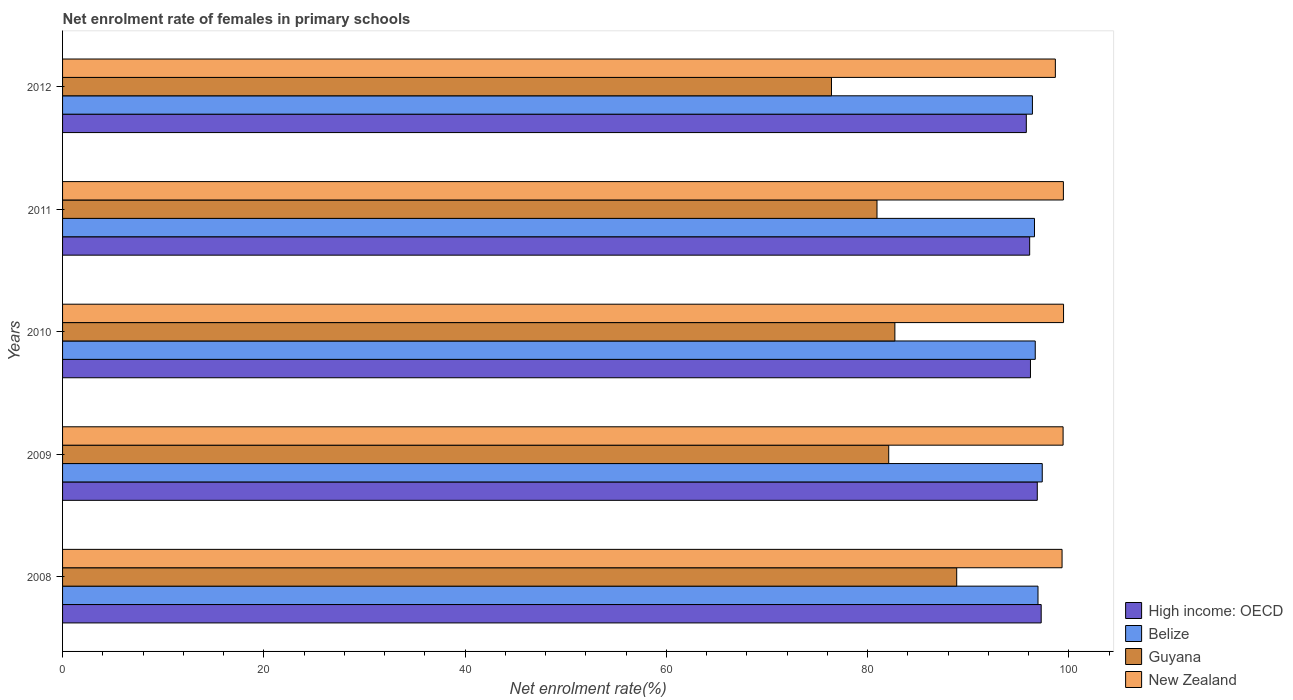How many groups of bars are there?
Ensure brevity in your answer.  5. Are the number of bars per tick equal to the number of legend labels?
Your response must be concise. Yes. Are the number of bars on each tick of the Y-axis equal?
Make the answer very short. Yes. How many bars are there on the 2nd tick from the top?
Ensure brevity in your answer.  4. How many bars are there on the 5th tick from the bottom?
Your answer should be compact. 4. In how many cases, is the number of bars for a given year not equal to the number of legend labels?
Keep it short and to the point. 0. What is the net enrolment rate of females in primary schools in High income: OECD in 2010?
Make the answer very short. 96.19. Across all years, what is the maximum net enrolment rate of females in primary schools in Guyana?
Provide a short and direct response. 88.86. Across all years, what is the minimum net enrolment rate of females in primary schools in New Zealand?
Keep it short and to the point. 98.67. What is the total net enrolment rate of females in primary schools in Guyana in the graph?
Your response must be concise. 411.05. What is the difference between the net enrolment rate of females in primary schools in Belize in 2008 and that in 2009?
Offer a terse response. -0.42. What is the difference between the net enrolment rate of females in primary schools in New Zealand in 2010 and the net enrolment rate of females in primary schools in Belize in 2009?
Your answer should be very brief. 2.12. What is the average net enrolment rate of females in primary schools in Belize per year?
Offer a terse response. 96.79. In the year 2012, what is the difference between the net enrolment rate of females in primary schools in High income: OECD and net enrolment rate of females in primary schools in Guyana?
Provide a short and direct response. 19.36. In how many years, is the net enrolment rate of females in primary schools in Belize greater than 8 %?
Ensure brevity in your answer.  5. What is the ratio of the net enrolment rate of females in primary schools in New Zealand in 2008 to that in 2011?
Offer a terse response. 1. Is the net enrolment rate of females in primary schools in Belize in 2009 less than that in 2010?
Offer a terse response. No. Is the difference between the net enrolment rate of females in primary schools in High income: OECD in 2008 and 2012 greater than the difference between the net enrolment rate of females in primary schools in Guyana in 2008 and 2012?
Make the answer very short. No. What is the difference between the highest and the second highest net enrolment rate of females in primary schools in Guyana?
Make the answer very short. 6.14. What is the difference between the highest and the lowest net enrolment rate of females in primary schools in High income: OECD?
Give a very brief answer. 1.48. Is it the case that in every year, the sum of the net enrolment rate of females in primary schools in High income: OECD and net enrolment rate of females in primary schools in New Zealand is greater than the sum of net enrolment rate of females in primary schools in Belize and net enrolment rate of females in primary schools in Guyana?
Offer a terse response. Yes. What does the 4th bar from the top in 2009 represents?
Keep it short and to the point. High income: OECD. What does the 1st bar from the bottom in 2010 represents?
Ensure brevity in your answer.  High income: OECD. Is it the case that in every year, the sum of the net enrolment rate of females in primary schools in Guyana and net enrolment rate of females in primary schools in High income: OECD is greater than the net enrolment rate of females in primary schools in Belize?
Your answer should be very brief. Yes. How many bars are there?
Offer a very short reply. 20. How many years are there in the graph?
Your response must be concise. 5. Are the values on the major ticks of X-axis written in scientific E-notation?
Make the answer very short. No. What is the title of the graph?
Give a very brief answer. Net enrolment rate of females in primary schools. What is the label or title of the X-axis?
Provide a short and direct response. Net enrolment rate(%). What is the Net enrolment rate(%) of High income: OECD in 2008?
Provide a short and direct response. 97.26. What is the Net enrolment rate(%) in Belize in 2008?
Make the answer very short. 96.94. What is the Net enrolment rate(%) in Guyana in 2008?
Your answer should be very brief. 88.86. What is the Net enrolment rate(%) in New Zealand in 2008?
Make the answer very short. 99.34. What is the Net enrolment rate(%) of High income: OECD in 2009?
Give a very brief answer. 96.87. What is the Net enrolment rate(%) of Belize in 2009?
Your answer should be very brief. 97.37. What is the Net enrolment rate(%) in Guyana in 2009?
Ensure brevity in your answer.  82.11. What is the Net enrolment rate(%) in New Zealand in 2009?
Offer a very short reply. 99.44. What is the Net enrolment rate(%) in High income: OECD in 2010?
Provide a short and direct response. 96.19. What is the Net enrolment rate(%) in Belize in 2010?
Your answer should be compact. 96.67. What is the Net enrolment rate(%) of Guyana in 2010?
Your answer should be compact. 82.72. What is the Net enrolment rate(%) of New Zealand in 2010?
Your answer should be compact. 99.48. What is the Net enrolment rate(%) of High income: OECD in 2011?
Ensure brevity in your answer.  96.12. What is the Net enrolment rate(%) in Belize in 2011?
Your answer should be very brief. 96.59. What is the Net enrolment rate(%) of Guyana in 2011?
Give a very brief answer. 80.94. What is the Net enrolment rate(%) of New Zealand in 2011?
Offer a very short reply. 99.47. What is the Net enrolment rate(%) of High income: OECD in 2012?
Provide a short and direct response. 95.78. What is the Net enrolment rate(%) in Belize in 2012?
Your answer should be compact. 96.39. What is the Net enrolment rate(%) in Guyana in 2012?
Provide a succinct answer. 76.42. What is the Net enrolment rate(%) in New Zealand in 2012?
Provide a succinct answer. 98.67. Across all years, what is the maximum Net enrolment rate(%) of High income: OECD?
Your answer should be compact. 97.26. Across all years, what is the maximum Net enrolment rate(%) in Belize?
Your response must be concise. 97.37. Across all years, what is the maximum Net enrolment rate(%) in Guyana?
Make the answer very short. 88.86. Across all years, what is the maximum Net enrolment rate(%) in New Zealand?
Keep it short and to the point. 99.48. Across all years, what is the minimum Net enrolment rate(%) in High income: OECD?
Your response must be concise. 95.78. Across all years, what is the minimum Net enrolment rate(%) of Belize?
Provide a succinct answer. 96.39. Across all years, what is the minimum Net enrolment rate(%) in Guyana?
Keep it short and to the point. 76.42. Across all years, what is the minimum Net enrolment rate(%) in New Zealand?
Offer a terse response. 98.67. What is the total Net enrolment rate(%) in High income: OECD in the graph?
Your answer should be compact. 482.22. What is the total Net enrolment rate(%) of Belize in the graph?
Ensure brevity in your answer.  483.96. What is the total Net enrolment rate(%) in Guyana in the graph?
Provide a short and direct response. 411.05. What is the total Net enrolment rate(%) in New Zealand in the graph?
Offer a very short reply. 496.39. What is the difference between the Net enrolment rate(%) in High income: OECD in 2008 and that in 2009?
Provide a succinct answer. 0.39. What is the difference between the Net enrolment rate(%) in Belize in 2008 and that in 2009?
Keep it short and to the point. -0.42. What is the difference between the Net enrolment rate(%) in Guyana in 2008 and that in 2009?
Your answer should be compact. 6.76. What is the difference between the Net enrolment rate(%) in New Zealand in 2008 and that in 2009?
Your answer should be very brief. -0.1. What is the difference between the Net enrolment rate(%) of High income: OECD in 2008 and that in 2010?
Keep it short and to the point. 1.07. What is the difference between the Net enrolment rate(%) in Belize in 2008 and that in 2010?
Make the answer very short. 0.27. What is the difference between the Net enrolment rate(%) in Guyana in 2008 and that in 2010?
Provide a short and direct response. 6.14. What is the difference between the Net enrolment rate(%) of New Zealand in 2008 and that in 2010?
Ensure brevity in your answer.  -0.15. What is the difference between the Net enrolment rate(%) of High income: OECD in 2008 and that in 2011?
Offer a very short reply. 1.15. What is the difference between the Net enrolment rate(%) of Guyana in 2008 and that in 2011?
Keep it short and to the point. 7.92. What is the difference between the Net enrolment rate(%) of New Zealand in 2008 and that in 2011?
Ensure brevity in your answer.  -0.13. What is the difference between the Net enrolment rate(%) in High income: OECD in 2008 and that in 2012?
Provide a short and direct response. 1.48. What is the difference between the Net enrolment rate(%) of Belize in 2008 and that in 2012?
Keep it short and to the point. 0.56. What is the difference between the Net enrolment rate(%) in Guyana in 2008 and that in 2012?
Offer a terse response. 12.44. What is the difference between the Net enrolment rate(%) in New Zealand in 2008 and that in 2012?
Provide a succinct answer. 0.67. What is the difference between the Net enrolment rate(%) in High income: OECD in 2009 and that in 2010?
Your response must be concise. 0.68. What is the difference between the Net enrolment rate(%) in Belize in 2009 and that in 2010?
Provide a short and direct response. 0.69. What is the difference between the Net enrolment rate(%) in Guyana in 2009 and that in 2010?
Provide a short and direct response. -0.61. What is the difference between the Net enrolment rate(%) in New Zealand in 2009 and that in 2010?
Give a very brief answer. -0.04. What is the difference between the Net enrolment rate(%) in High income: OECD in 2009 and that in 2011?
Keep it short and to the point. 0.76. What is the difference between the Net enrolment rate(%) in Belize in 2009 and that in 2011?
Offer a terse response. 0.77. What is the difference between the Net enrolment rate(%) in Guyana in 2009 and that in 2011?
Offer a very short reply. 1.17. What is the difference between the Net enrolment rate(%) in New Zealand in 2009 and that in 2011?
Offer a terse response. -0.03. What is the difference between the Net enrolment rate(%) of High income: OECD in 2009 and that in 2012?
Make the answer very short. 1.09. What is the difference between the Net enrolment rate(%) in Belize in 2009 and that in 2012?
Give a very brief answer. 0.98. What is the difference between the Net enrolment rate(%) in Guyana in 2009 and that in 2012?
Your answer should be compact. 5.69. What is the difference between the Net enrolment rate(%) in New Zealand in 2009 and that in 2012?
Your response must be concise. 0.77. What is the difference between the Net enrolment rate(%) in High income: OECD in 2010 and that in 2011?
Provide a short and direct response. 0.08. What is the difference between the Net enrolment rate(%) of Belize in 2010 and that in 2011?
Keep it short and to the point. 0.08. What is the difference between the Net enrolment rate(%) in Guyana in 2010 and that in 2011?
Provide a short and direct response. 1.78. What is the difference between the Net enrolment rate(%) of New Zealand in 2010 and that in 2011?
Keep it short and to the point. 0.02. What is the difference between the Net enrolment rate(%) of High income: OECD in 2010 and that in 2012?
Your answer should be compact. 0.41. What is the difference between the Net enrolment rate(%) in Belize in 2010 and that in 2012?
Provide a succinct answer. 0.28. What is the difference between the Net enrolment rate(%) of Guyana in 2010 and that in 2012?
Your answer should be compact. 6.3. What is the difference between the Net enrolment rate(%) of New Zealand in 2010 and that in 2012?
Your answer should be compact. 0.81. What is the difference between the Net enrolment rate(%) of High income: OECD in 2011 and that in 2012?
Give a very brief answer. 0.33. What is the difference between the Net enrolment rate(%) of Belize in 2011 and that in 2012?
Make the answer very short. 0.21. What is the difference between the Net enrolment rate(%) in Guyana in 2011 and that in 2012?
Your answer should be very brief. 4.52. What is the difference between the Net enrolment rate(%) in New Zealand in 2011 and that in 2012?
Provide a succinct answer. 0.8. What is the difference between the Net enrolment rate(%) of High income: OECD in 2008 and the Net enrolment rate(%) of Belize in 2009?
Make the answer very short. -0.11. What is the difference between the Net enrolment rate(%) in High income: OECD in 2008 and the Net enrolment rate(%) in Guyana in 2009?
Offer a terse response. 15.15. What is the difference between the Net enrolment rate(%) of High income: OECD in 2008 and the Net enrolment rate(%) of New Zealand in 2009?
Your response must be concise. -2.18. What is the difference between the Net enrolment rate(%) of Belize in 2008 and the Net enrolment rate(%) of Guyana in 2009?
Your answer should be compact. 14.84. What is the difference between the Net enrolment rate(%) in Belize in 2008 and the Net enrolment rate(%) in New Zealand in 2009?
Your answer should be compact. -2.49. What is the difference between the Net enrolment rate(%) in Guyana in 2008 and the Net enrolment rate(%) in New Zealand in 2009?
Provide a short and direct response. -10.57. What is the difference between the Net enrolment rate(%) of High income: OECD in 2008 and the Net enrolment rate(%) of Belize in 2010?
Ensure brevity in your answer.  0.59. What is the difference between the Net enrolment rate(%) of High income: OECD in 2008 and the Net enrolment rate(%) of Guyana in 2010?
Provide a short and direct response. 14.54. What is the difference between the Net enrolment rate(%) in High income: OECD in 2008 and the Net enrolment rate(%) in New Zealand in 2010?
Keep it short and to the point. -2.22. What is the difference between the Net enrolment rate(%) of Belize in 2008 and the Net enrolment rate(%) of Guyana in 2010?
Your response must be concise. 14.22. What is the difference between the Net enrolment rate(%) in Belize in 2008 and the Net enrolment rate(%) in New Zealand in 2010?
Make the answer very short. -2.54. What is the difference between the Net enrolment rate(%) of Guyana in 2008 and the Net enrolment rate(%) of New Zealand in 2010?
Keep it short and to the point. -10.62. What is the difference between the Net enrolment rate(%) in High income: OECD in 2008 and the Net enrolment rate(%) in Guyana in 2011?
Provide a short and direct response. 16.32. What is the difference between the Net enrolment rate(%) of High income: OECD in 2008 and the Net enrolment rate(%) of New Zealand in 2011?
Offer a terse response. -2.21. What is the difference between the Net enrolment rate(%) in Belize in 2008 and the Net enrolment rate(%) in Guyana in 2011?
Offer a terse response. 16. What is the difference between the Net enrolment rate(%) in Belize in 2008 and the Net enrolment rate(%) in New Zealand in 2011?
Ensure brevity in your answer.  -2.52. What is the difference between the Net enrolment rate(%) of Guyana in 2008 and the Net enrolment rate(%) of New Zealand in 2011?
Your answer should be very brief. -10.6. What is the difference between the Net enrolment rate(%) in High income: OECD in 2008 and the Net enrolment rate(%) in Belize in 2012?
Offer a very short reply. 0.87. What is the difference between the Net enrolment rate(%) of High income: OECD in 2008 and the Net enrolment rate(%) of Guyana in 2012?
Your answer should be very brief. 20.84. What is the difference between the Net enrolment rate(%) of High income: OECD in 2008 and the Net enrolment rate(%) of New Zealand in 2012?
Your answer should be compact. -1.41. What is the difference between the Net enrolment rate(%) of Belize in 2008 and the Net enrolment rate(%) of Guyana in 2012?
Provide a short and direct response. 20.52. What is the difference between the Net enrolment rate(%) of Belize in 2008 and the Net enrolment rate(%) of New Zealand in 2012?
Your response must be concise. -1.72. What is the difference between the Net enrolment rate(%) in Guyana in 2008 and the Net enrolment rate(%) in New Zealand in 2012?
Your answer should be compact. -9.8. What is the difference between the Net enrolment rate(%) of High income: OECD in 2009 and the Net enrolment rate(%) of Belize in 2010?
Offer a terse response. 0.2. What is the difference between the Net enrolment rate(%) in High income: OECD in 2009 and the Net enrolment rate(%) in Guyana in 2010?
Provide a succinct answer. 14.15. What is the difference between the Net enrolment rate(%) of High income: OECD in 2009 and the Net enrolment rate(%) of New Zealand in 2010?
Make the answer very short. -2.61. What is the difference between the Net enrolment rate(%) of Belize in 2009 and the Net enrolment rate(%) of Guyana in 2010?
Give a very brief answer. 14.65. What is the difference between the Net enrolment rate(%) in Belize in 2009 and the Net enrolment rate(%) in New Zealand in 2010?
Ensure brevity in your answer.  -2.12. What is the difference between the Net enrolment rate(%) in Guyana in 2009 and the Net enrolment rate(%) in New Zealand in 2010?
Your answer should be compact. -17.38. What is the difference between the Net enrolment rate(%) in High income: OECD in 2009 and the Net enrolment rate(%) in Belize in 2011?
Keep it short and to the point. 0.28. What is the difference between the Net enrolment rate(%) in High income: OECD in 2009 and the Net enrolment rate(%) in Guyana in 2011?
Your answer should be very brief. 15.93. What is the difference between the Net enrolment rate(%) in High income: OECD in 2009 and the Net enrolment rate(%) in New Zealand in 2011?
Your answer should be very brief. -2.59. What is the difference between the Net enrolment rate(%) in Belize in 2009 and the Net enrolment rate(%) in Guyana in 2011?
Your answer should be compact. 16.42. What is the difference between the Net enrolment rate(%) of Belize in 2009 and the Net enrolment rate(%) of New Zealand in 2011?
Your answer should be very brief. -2.1. What is the difference between the Net enrolment rate(%) of Guyana in 2009 and the Net enrolment rate(%) of New Zealand in 2011?
Ensure brevity in your answer.  -17.36. What is the difference between the Net enrolment rate(%) in High income: OECD in 2009 and the Net enrolment rate(%) in Belize in 2012?
Your response must be concise. 0.48. What is the difference between the Net enrolment rate(%) in High income: OECD in 2009 and the Net enrolment rate(%) in Guyana in 2012?
Your answer should be very brief. 20.45. What is the difference between the Net enrolment rate(%) of High income: OECD in 2009 and the Net enrolment rate(%) of New Zealand in 2012?
Your answer should be very brief. -1.8. What is the difference between the Net enrolment rate(%) of Belize in 2009 and the Net enrolment rate(%) of Guyana in 2012?
Offer a terse response. 20.95. What is the difference between the Net enrolment rate(%) of Belize in 2009 and the Net enrolment rate(%) of New Zealand in 2012?
Ensure brevity in your answer.  -1.3. What is the difference between the Net enrolment rate(%) of Guyana in 2009 and the Net enrolment rate(%) of New Zealand in 2012?
Your answer should be compact. -16.56. What is the difference between the Net enrolment rate(%) of High income: OECD in 2010 and the Net enrolment rate(%) of Belize in 2011?
Your response must be concise. -0.4. What is the difference between the Net enrolment rate(%) in High income: OECD in 2010 and the Net enrolment rate(%) in Guyana in 2011?
Your response must be concise. 15.25. What is the difference between the Net enrolment rate(%) of High income: OECD in 2010 and the Net enrolment rate(%) of New Zealand in 2011?
Provide a short and direct response. -3.27. What is the difference between the Net enrolment rate(%) of Belize in 2010 and the Net enrolment rate(%) of Guyana in 2011?
Provide a succinct answer. 15.73. What is the difference between the Net enrolment rate(%) in Belize in 2010 and the Net enrolment rate(%) in New Zealand in 2011?
Provide a succinct answer. -2.8. What is the difference between the Net enrolment rate(%) in Guyana in 2010 and the Net enrolment rate(%) in New Zealand in 2011?
Provide a succinct answer. -16.75. What is the difference between the Net enrolment rate(%) of High income: OECD in 2010 and the Net enrolment rate(%) of Belize in 2012?
Offer a very short reply. -0.19. What is the difference between the Net enrolment rate(%) of High income: OECD in 2010 and the Net enrolment rate(%) of Guyana in 2012?
Offer a very short reply. 19.78. What is the difference between the Net enrolment rate(%) in High income: OECD in 2010 and the Net enrolment rate(%) in New Zealand in 2012?
Offer a very short reply. -2.47. What is the difference between the Net enrolment rate(%) of Belize in 2010 and the Net enrolment rate(%) of Guyana in 2012?
Ensure brevity in your answer.  20.25. What is the difference between the Net enrolment rate(%) in Belize in 2010 and the Net enrolment rate(%) in New Zealand in 2012?
Ensure brevity in your answer.  -2. What is the difference between the Net enrolment rate(%) of Guyana in 2010 and the Net enrolment rate(%) of New Zealand in 2012?
Your answer should be compact. -15.95. What is the difference between the Net enrolment rate(%) of High income: OECD in 2011 and the Net enrolment rate(%) of Belize in 2012?
Provide a short and direct response. -0.27. What is the difference between the Net enrolment rate(%) in High income: OECD in 2011 and the Net enrolment rate(%) in Guyana in 2012?
Keep it short and to the point. 19.7. What is the difference between the Net enrolment rate(%) in High income: OECD in 2011 and the Net enrolment rate(%) in New Zealand in 2012?
Keep it short and to the point. -2.55. What is the difference between the Net enrolment rate(%) in Belize in 2011 and the Net enrolment rate(%) in Guyana in 2012?
Offer a terse response. 20.18. What is the difference between the Net enrolment rate(%) in Belize in 2011 and the Net enrolment rate(%) in New Zealand in 2012?
Ensure brevity in your answer.  -2.07. What is the difference between the Net enrolment rate(%) in Guyana in 2011 and the Net enrolment rate(%) in New Zealand in 2012?
Your response must be concise. -17.73. What is the average Net enrolment rate(%) of High income: OECD per year?
Ensure brevity in your answer.  96.44. What is the average Net enrolment rate(%) in Belize per year?
Your answer should be compact. 96.79. What is the average Net enrolment rate(%) in Guyana per year?
Provide a short and direct response. 82.21. What is the average Net enrolment rate(%) of New Zealand per year?
Provide a succinct answer. 99.28. In the year 2008, what is the difference between the Net enrolment rate(%) in High income: OECD and Net enrolment rate(%) in Belize?
Offer a very short reply. 0.32. In the year 2008, what is the difference between the Net enrolment rate(%) in High income: OECD and Net enrolment rate(%) in Guyana?
Give a very brief answer. 8.4. In the year 2008, what is the difference between the Net enrolment rate(%) in High income: OECD and Net enrolment rate(%) in New Zealand?
Offer a very short reply. -2.08. In the year 2008, what is the difference between the Net enrolment rate(%) in Belize and Net enrolment rate(%) in Guyana?
Offer a terse response. 8.08. In the year 2008, what is the difference between the Net enrolment rate(%) in Belize and Net enrolment rate(%) in New Zealand?
Provide a succinct answer. -2.39. In the year 2008, what is the difference between the Net enrolment rate(%) in Guyana and Net enrolment rate(%) in New Zealand?
Keep it short and to the point. -10.47. In the year 2009, what is the difference between the Net enrolment rate(%) in High income: OECD and Net enrolment rate(%) in Belize?
Provide a succinct answer. -0.49. In the year 2009, what is the difference between the Net enrolment rate(%) of High income: OECD and Net enrolment rate(%) of Guyana?
Give a very brief answer. 14.77. In the year 2009, what is the difference between the Net enrolment rate(%) of High income: OECD and Net enrolment rate(%) of New Zealand?
Your response must be concise. -2.57. In the year 2009, what is the difference between the Net enrolment rate(%) in Belize and Net enrolment rate(%) in Guyana?
Give a very brief answer. 15.26. In the year 2009, what is the difference between the Net enrolment rate(%) of Belize and Net enrolment rate(%) of New Zealand?
Offer a very short reply. -2.07. In the year 2009, what is the difference between the Net enrolment rate(%) of Guyana and Net enrolment rate(%) of New Zealand?
Make the answer very short. -17.33. In the year 2010, what is the difference between the Net enrolment rate(%) of High income: OECD and Net enrolment rate(%) of Belize?
Give a very brief answer. -0.48. In the year 2010, what is the difference between the Net enrolment rate(%) in High income: OECD and Net enrolment rate(%) in Guyana?
Provide a short and direct response. 13.48. In the year 2010, what is the difference between the Net enrolment rate(%) in High income: OECD and Net enrolment rate(%) in New Zealand?
Make the answer very short. -3.29. In the year 2010, what is the difference between the Net enrolment rate(%) of Belize and Net enrolment rate(%) of Guyana?
Ensure brevity in your answer.  13.95. In the year 2010, what is the difference between the Net enrolment rate(%) of Belize and Net enrolment rate(%) of New Zealand?
Your response must be concise. -2.81. In the year 2010, what is the difference between the Net enrolment rate(%) of Guyana and Net enrolment rate(%) of New Zealand?
Provide a succinct answer. -16.76. In the year 2011, what is the difference between the Net enrolment rate(%) in High income: OECD and Net enrolment rate(%) in Belize?
Offer a terse response. -0.48. In the year 2011, what is the difference between the Net enrolment rate(%) in High income: OECD and Net enrolment rate(%) in Guyana?
Give a very brief answer. 15.17. In the year 2011, what is the difference between the Net enrolment rate(%) in High income: OECD and Net enrolment rate(%) in New Zealand?
Offer a very short reply. -3.35. In the year 2011, what is the difference between the Net enrolment rate(%) in Belize and Net enrolment rate(%) in Guyana?
Offer a terse response. 15.65. In the year 2011, what is the difference between the Net enrolment rate(%) of Belize and Net enrolment rate(%) of New Zealand?
Provide a succinct answer. -2.87. In the year 2011, what is the difference between the Net enrolment rate(%) in Guyana and Net enrolment rate(%) in New Zealand?
Give a very brief answer. -18.52. In the year 2012, what is the difference between the Net enrolment rate(%) of High income: OECD and Net enrolment rate(%) of Belize?
Give a very brief answer. -0.61. In the year 2012, what is the difference between the Net enrolment rate(%) of High income: OECD and Net enrolment rate(%) of Guyana?
Keep it short and to the point. 19.36. In the year 2012, what is the difference between the Net enrolment rate(%) of High income: OECD and Net enrolment rate(%) of New Zealand?
Give a very brief answer. -2.89. In the year 2012, what is the difference between the Net enrolment rate(%) of Belize and Net enrolment rate(%) of Guyana?
Provide a short and direct response. 19.97. In the year 2012, what is the difference between the Net enrolment rate(%) of Belize and Net enrolment rate(%) of New Zealand?
Your answer should be compact. -2.28. In the year 2012, what is the difference between the Net enrolment rate(%) of Guyana and Net enrolment rate(%) of New Zealand?
Keep it short and to the point. -22.25. What is the ratio of the Net enrolment rate(%) of High income: OECD in 2008 to that in 2009?
Ensure brevity in your answer.  1. What is the ratio of the Net enrolment rate(%) in Belize in 2008 to that in 2009?
Make the answer very short. 1. What is the ratio of the Net enrolment rate(%) in Guyana in 2008 to that in 2009?
Give a very brief answer. 1.08. What is the ratio of the Net enrolment rate(%) of New Zealand in 2008 to that in 2009?
Provide a succinct answer. 1. What is the ratio of the Net enrolment rate(%) in High income: OECD in 2008 to that in 2010?
Your answer should be very brief. 1.01. What is the ratio of the Net enrolment rate(%) in Guyana in 2008 to that in 2010?
Ensure brevity in your answer.  1.07. What is the ratio of the Net enrolment rate(%) in New Zealand in 2008 to that in 2010?
Provide a short and direct response. 1. What is the ratio of the Net enrolment rate(%) in High income: OECD in 2008 to that in 2011?
Your answer should be compact. 1.01. What is the ratio of the Net enrolment rate(%) in Guyana in 2008 to that in 2011?
Offer a terse response. 1.1. What is the ratio of the Net enrolment rate(%) of New Zealand in 2008 to that in 2011?
Provide a succinct answer. 1. What is the ratio of the Net enrolment rate(%) of High income: OECD in 2008 to that in 2012?
Your answer should be very brief. 1.02. What is the ratio of the Net enrolment rate(%) of Belize in 2008 to that in 2012?
Your answer should be very brief. 1.01. What is the ratio of the Net enrolment rate(%) of Guyana in 2008 to that in 2012?
Keep it short and to the point. 1.16. What is the ratio of the Net enrolment rate(%) in New Zealand in 2008 to that in 2012?
Your answer should be compact. 1.01. What is the ratio of the Net enrolment rate(%) in High income: OECD in 2009 to that in 2010?
Your answer should be very brief. 1.01. What is the ratio of the Net enrolment rate(%) of Belize in 2009 to that in 2010?
Your answer should be very brief. 1.01. What is the ratio of the Net enrolment rate(%) in New Zealand in 2009 to that in 2010?
Offer a terse response. 1. What is the ratio of the Net enrolment rate(%) of High income: OECD in 2009 to that in 2011?
Give a very brief answer. 1.01. What is the ratio of the Net enrolment rate(%) in Guyana in 2009 to that in 2011?
Your answer should be compact. 1.01. What is the ratio of the Net enrolment rate(%) of High income: OECD in 2009 to that in 2012?
Provide a short and direct response. 1.01. What is the ratio of the Net enrolment rate(%) in Belize in 2009 to that in 2012?
Keep it short and to the point. 1.01. What is the ratio of the Net enrolment rate(%) in Guyana in 2009 to that in 2012?
Your response must be concise. 1.07. What is the ratio of the Net enrolment rate(%) of New Zealand in 2009 to that in 2012?
Provide a succinct answer. 1.01. What is the ratio of the Net enrolment rate(%) of Belize in 2010 to that in 2011?
Your response must be concise. 1. What is the ratio of the Net enrolment rate(%) of High income: OECD in 2010 to that in 2012?
Ensure brevity in your answer.  1. What is the ratio of the Net enrolment rate(%) in Guyana in 2010 to that in 2012?
Offer a terse response. 1.08. What is the ratio of the Net enrolment rate(%) in New Zealand in 2010 to that in 2012?
Provide a succinct answer. 1.01. What is the ratio of the Net enrolment rate(%) in High income: OECD in 2011 to that in 2012?
Make the answer very short. 1. What is the ratio of the Net enrolment rate(%) of Belize in 2011 to that in 2012?
Give a very brief answer. 1. What is the ratio of the Net enrolment rate(%) of Guyana in 2011 to that in 2012?
Your response must be concise. 1.06. What is the difference between the highest and the second highest Net enrolment rate(%) in High income: OECD?
Keep it short and to the point. 0.39. What is the difference between the highest and the second highest Net enrolment rate(%) in Belize?
Provide a succinct answer. 0.42. What is the difference between the highest and the second highest Net enrolment rate(%) in Guyana?
Provide a succinct answer. 6.14. What is the difference between the highest and the second highest Net enrolment rate(%) of New Zealand?
Provide a short and direct response. 0.02. What is the difference between the highest and the lowest Net enrolment rate(%) of High income: OECD?
Provide a succinct answer. 1.48. What is the difference between the highest and the lowest Net enrolment rate(%) of Belize?
Your response must be concise. 0.98. What is the difference between the highest and the lowest Net enrolment rate(%) in Guyana?
Your answer should be compact. 12.44. What is the difference between the highest and the lowest Net enrolment rate(%) in New Zealand?
Offer a very short reply. 0.81. 